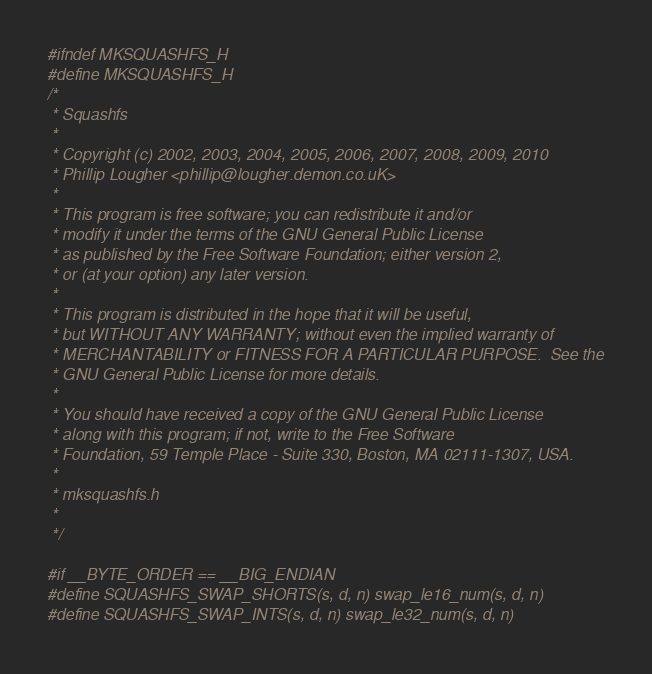Convert code to text. <code><loc_0><loc_0><loc_500><loc_500><_C_>#ifndef MKSQUASHFS_H
#define MKSQUASHFS_H
/*
 * Squashfs
 *
 * Copyright (c) 2002, 2003, 2004, 2005, 2006, 2007, 2008, 2009, 2010
 * Phillip Lougher <phillip@lougher.demon.co.uK>
 *
 * This program is free software; you can redistribute it and/or
 * modify it under the terms of the GNU General Public License
 * as published by the Free Software Foundation; either version 2,
 * or (at your option) any later version.
 *
 * This program is distributed in the hope that it will be useful,
 * but WITHOUT ANY WARRANTY; without even the implied warranty of
 * MERCHANTABILITY or FITNESS FOR A PARTICULAR PURPOSE.  See the
 * GNU General Public License for more details.
 *
 * You should have received a copy of the GNU General Public License
 * along with this program; if not, write to the Free Software
 * Foundation, 59 Temple Place - Suite 330, Boston, MA 02111-1307, USA.
 *
 * mksquashfs.h
 *
 */

#if __BYTE_ORDER == __BIG_ENDIAN
#define SQUASHFS_SWAP_SHORTS(s, d, n) swap_le16_num(s, d, n)
#define SQUASHFS_SWAP_INTS(s, d, n) swap_le32_num(s, d, n)</code> 